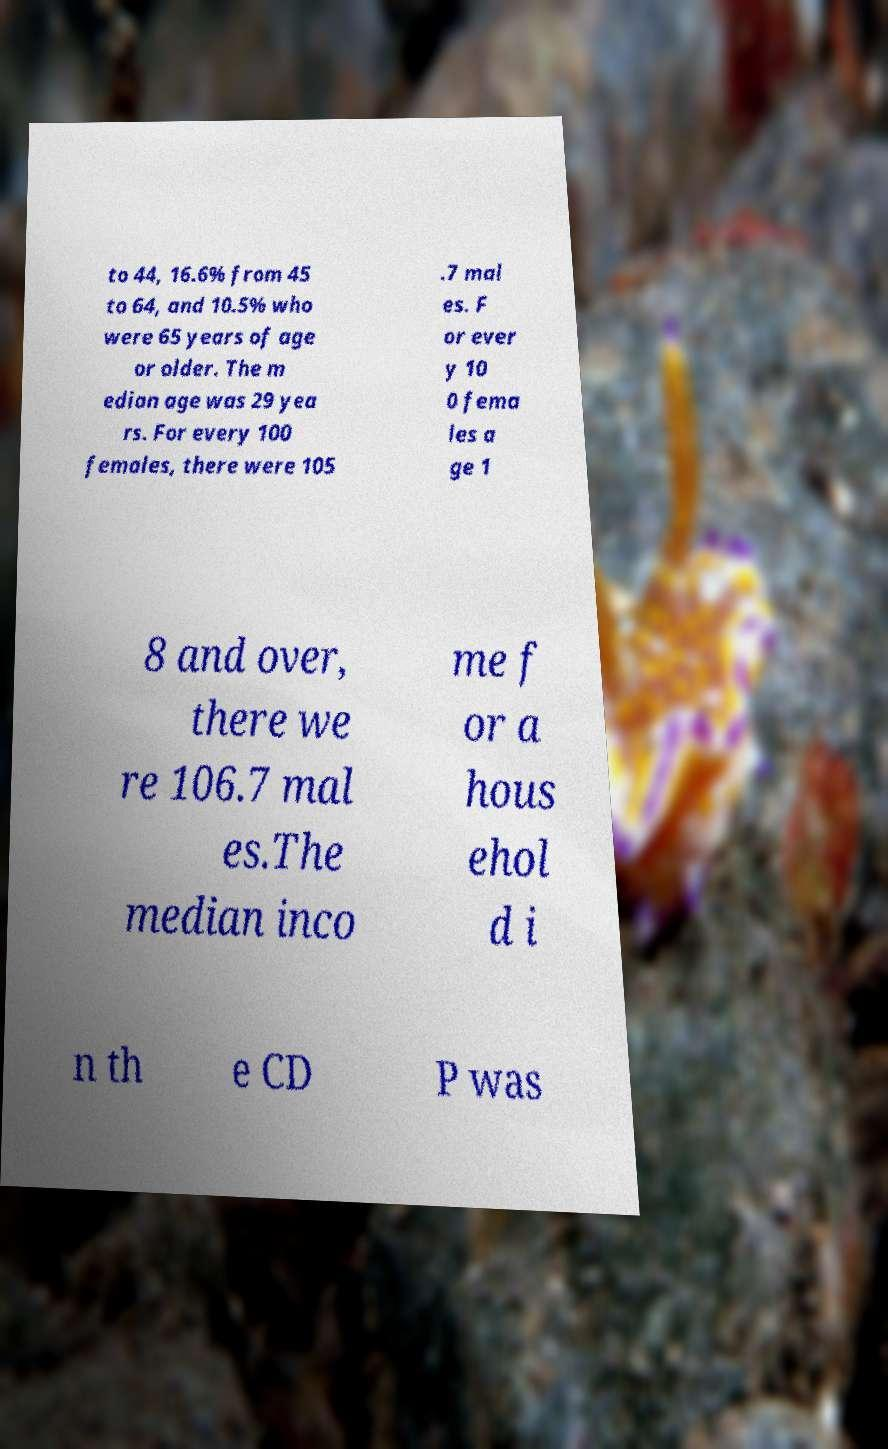Can you accurately transcribe the text from the provided image for me? to 44, 16.6% from 45 to 64, and 10.5% who were 65 years of age or older. The m edian age was 29 yea rs. For every 100 females, there were 105 .7 mal es. F or ever y 10 0 fema les a ge 1 8 and over, there we re 106.7 mal es.The median inco me f or a hous ehol d i n th e CD P was 